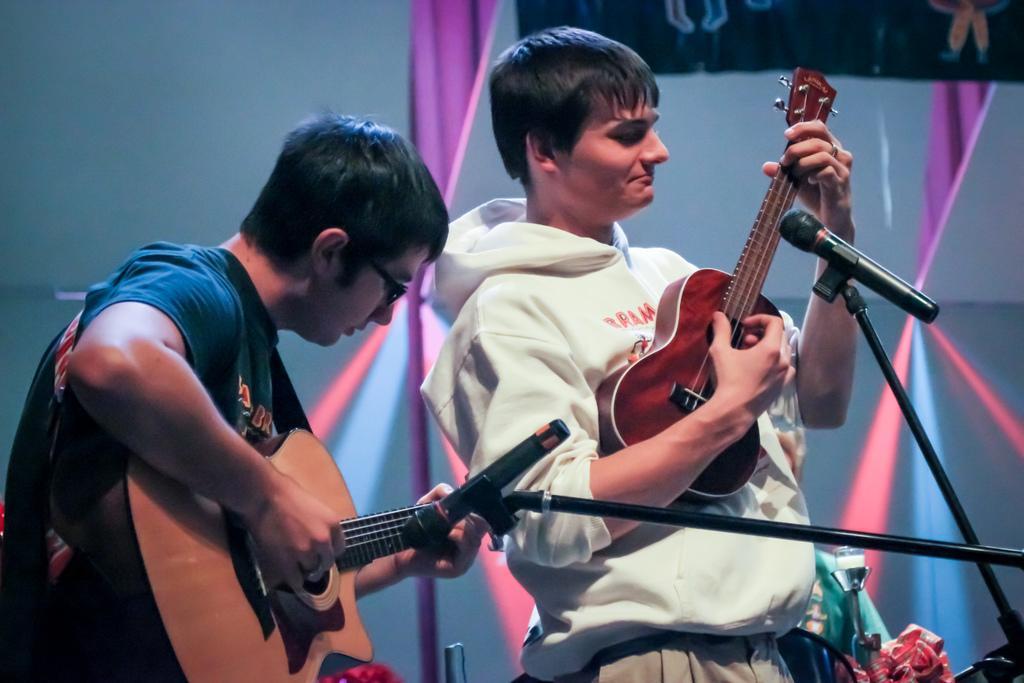Please provide a concise description of this image. In the middle there is a man he wear white jacket and trouser he is playing guitar. On the left there is a man he wear blue t shirt ,he is playing guitar. In this image there are two mic stands. In the background there is a screen. 